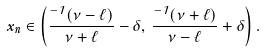Convert formula to latex. <formula><loc_0><loc_0><loc_500><loc_500>x _ { n } \in \left ( \frac { \Phi ^ { - 1 } ( \nu - \ell ) } { \nu + \ell } - \delta , \, \frac { \Phi ^ { - 1 } ( \nu + \ell ) } { \nu - \ell } + \delta \right ) .</formula> 